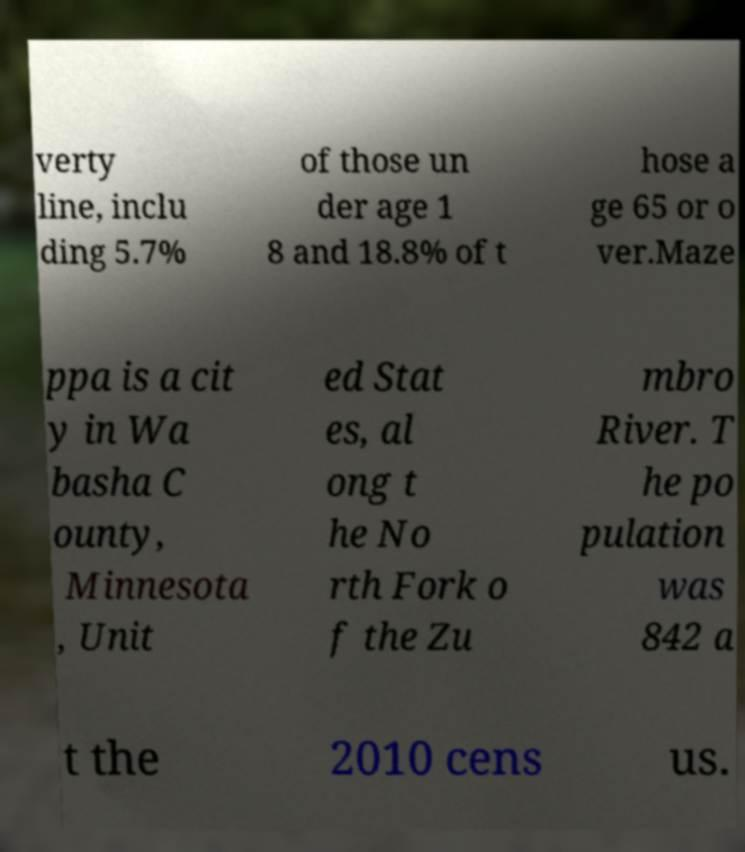Could you assist in decoding the text presented in this image and type it out clearly? verty line, inclu ding 5.7% of those un der age 1 8 and 18.8% of t hose a ge 65 or o ver.Maze ppa is a cit y in Wa basha C ounty, Minnesota , Unit ed Stat es, al ong t he No rth Fork o f the Zu mbro River. T he po pulation was 842 a t the 2010 cens us. 